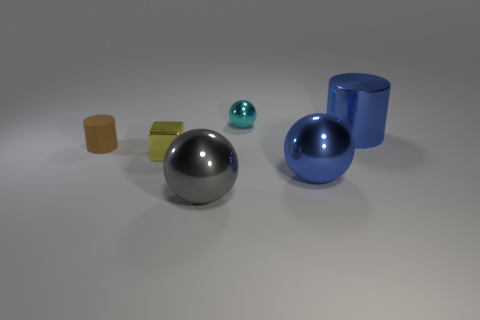Add 2 gray spheres. How many objects exist? 8 Subtract all cylinders. How many objects are left? 4 Subtract 1 cyan spheres. How many objects are left? 5 Subtract all rubber cylinders. Subtract all large cylinders. How many objects are left? 4 Add 4 tiny cyan shiny objects. How many tiny cyan shiny objects are left? 5 Add 1 big gray metallic balls. How many big gray metallic balls exist? 2 